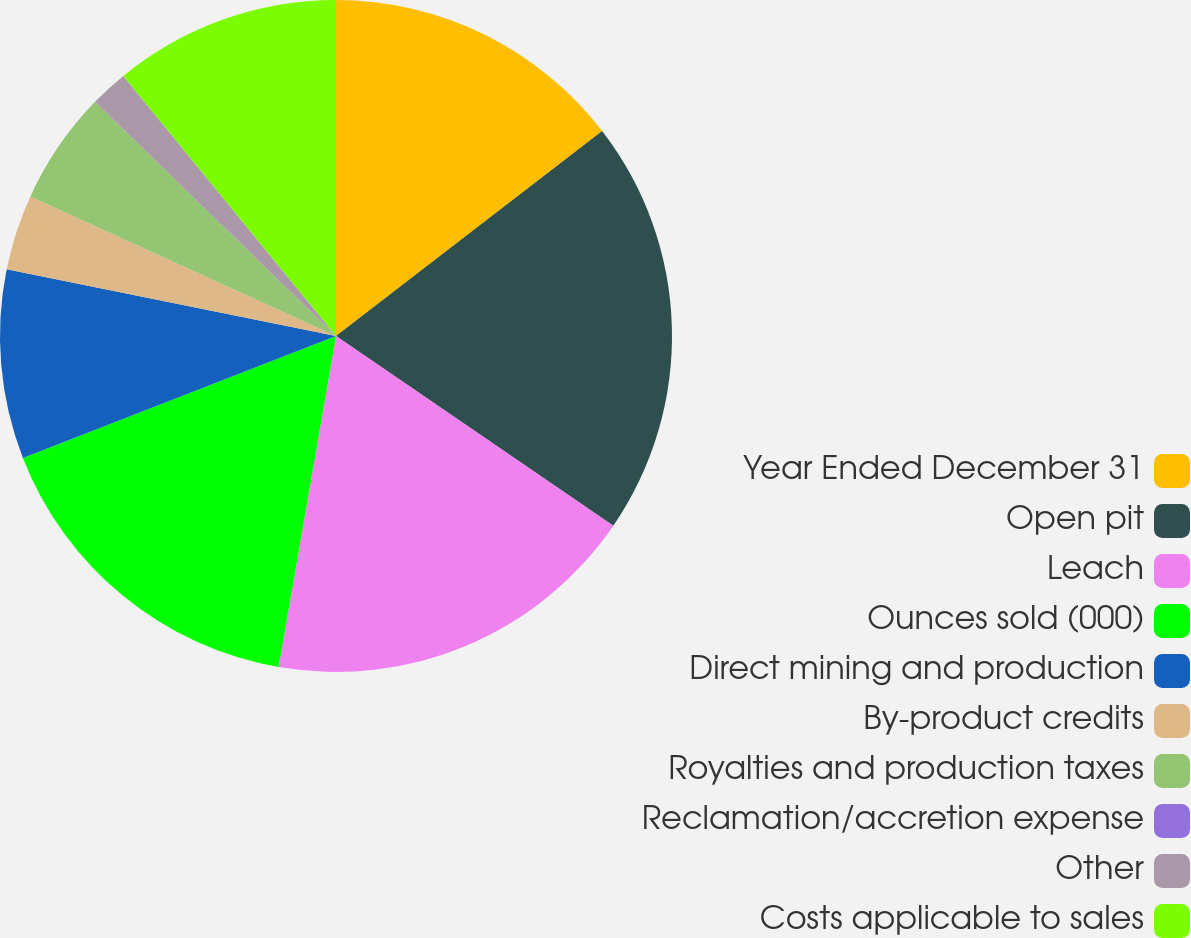Convert chart to OTSL. <chart><loc_0><loc_0><loc_500><loc_500><pie_chart><fcel>Year Ended December 31<fcel>Open pit<fcel>Leach<fcel>Ounces sold (000)<fcel>Direct mining and production<fcel>By-product credits<fcel>Royalties and production taxes<fcel>Reclamation/accretion expense<fcel>Other<fcel>Costs applicable to sales<nl><fcel>14.55%<fcel>20.0%<fcel>18.18%<fcel>16.36%<fcel>9.09%<fcel>3.64%<fcel>5.45%<fcel>0.0%<fcel>1.82%<fcel>10.91%<nl></chart> 